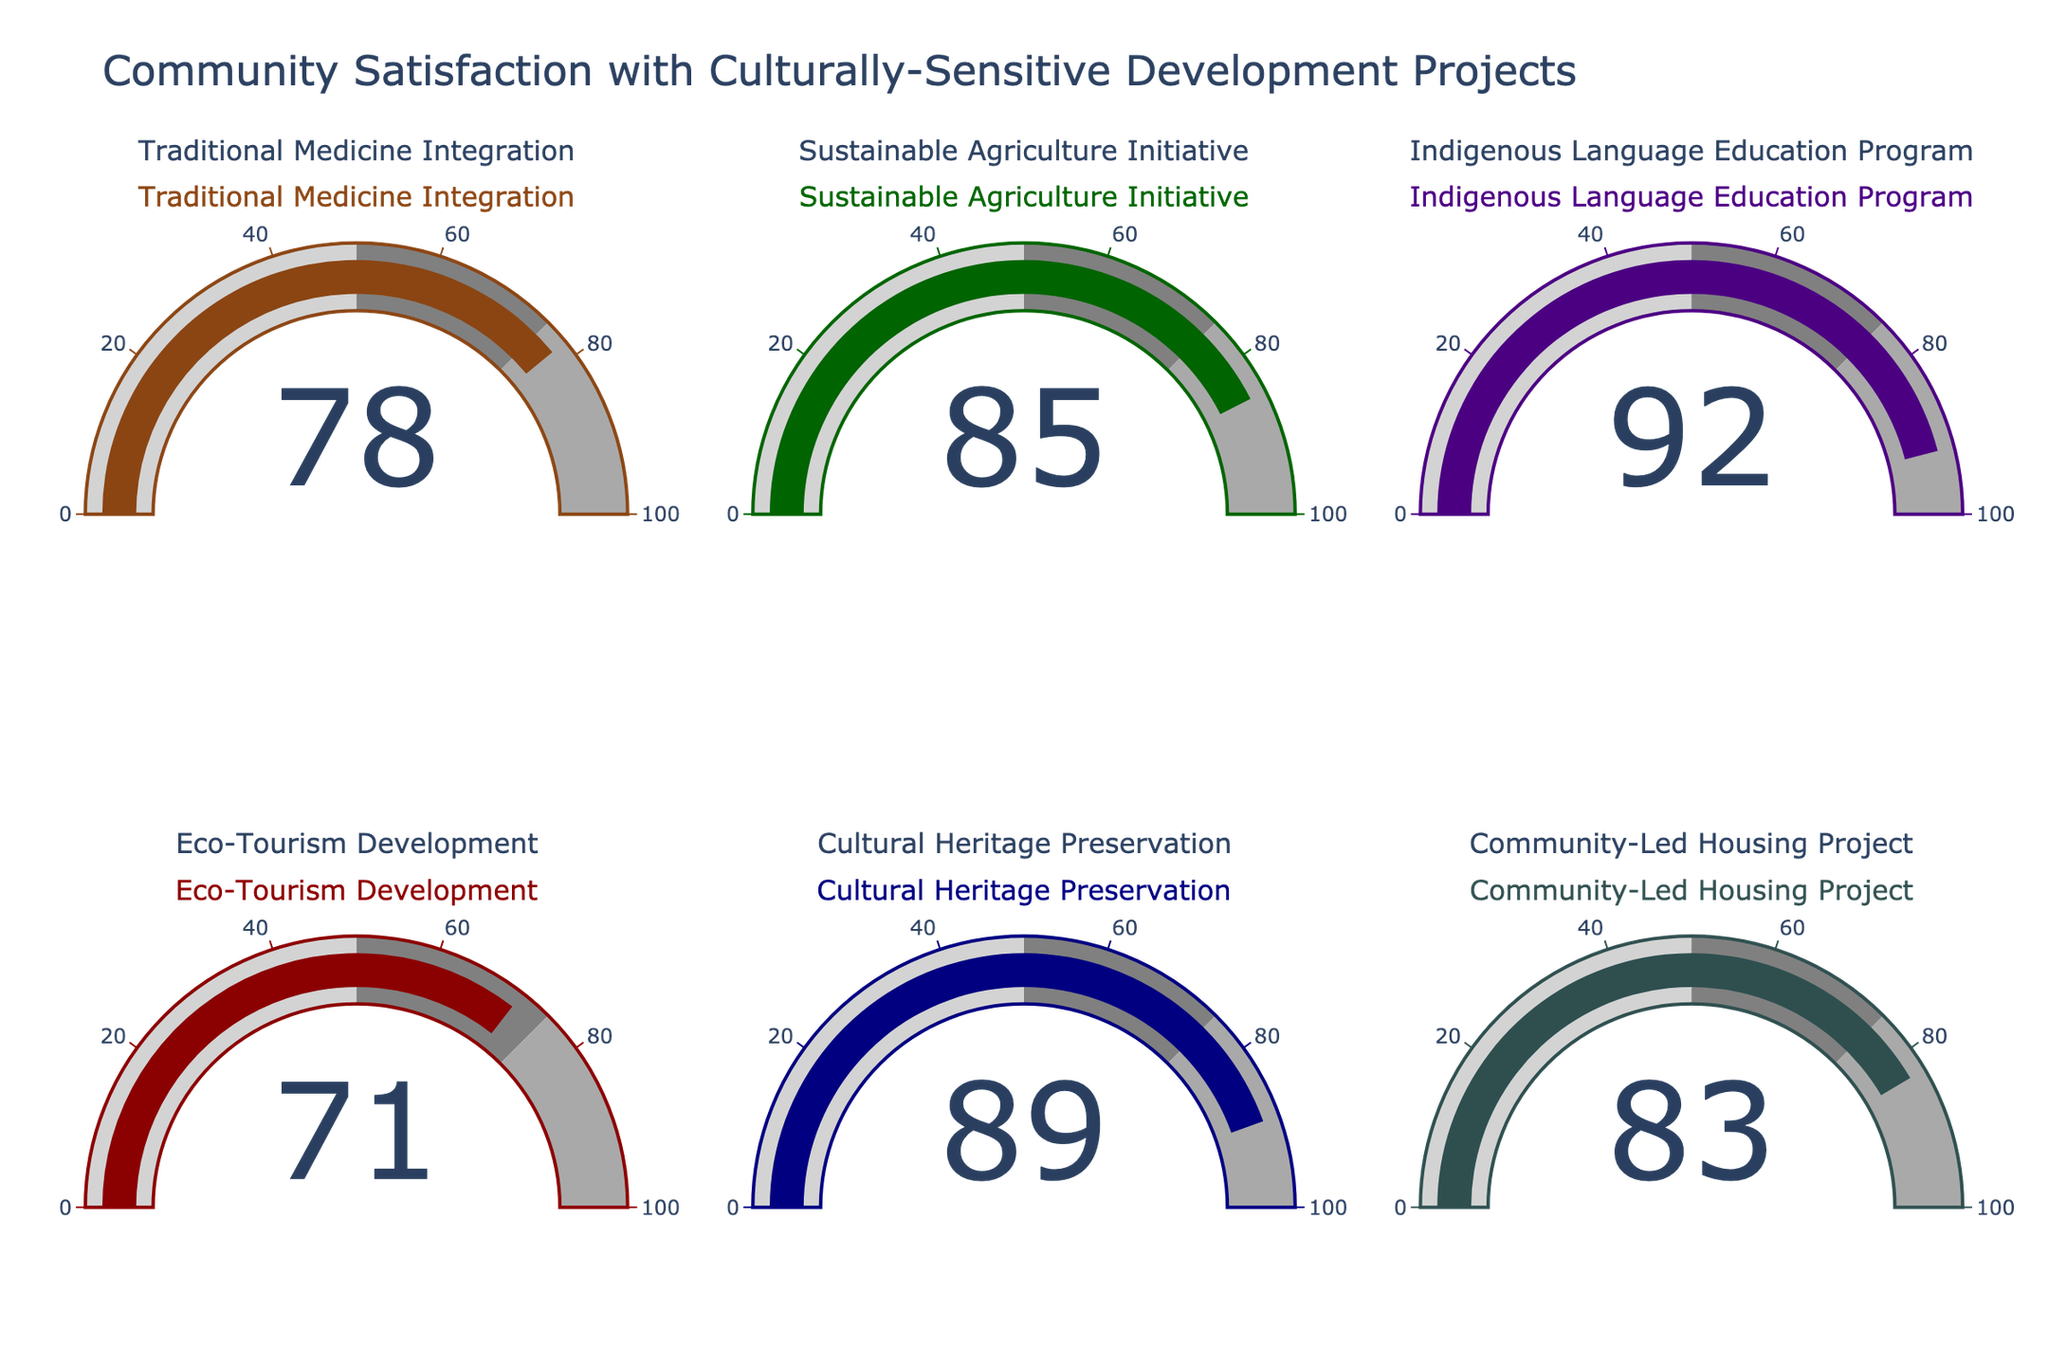What's the highest satisfaction level shown on the chart? The highest satisfaction level is shown in the gauge for the Indigenous Language Education Program, with a level of 92.
Answer: 92 Which project has the lowest satisfaction level? The Eco-Tourism Development project has the lowest satisfaction level, which is indicated as 71 on the gauge.
Answer: Eco-Tourism Development How many projects have a satisfaction level above 80? By counting the number of gauges with a value above 80: Traditional Medicine Integration (78) is below 80, Sustainable Agriculture Initiative (85) is above 80, Indigenous Language Education Program (92) is above 80, Eco-Tourism Development (71) is below 80, Cultural Heritage Preservation (89) is above 80, Community-Led Housing Project (83) is above 80. So, there are four projects with satisfaction levels above 80.
Answer: 4 What is the average satisfaction level for all projects? Sum all satisfaction levels: 78 (Traditional Medicine Integration) + 85 (Sustainable Agriculture Initiative) + 92 (Indigenous Language Education Program) + 71 (Eco-Tourism Development) + 89 (Cultural Heritage Preservation) + 83 (Community-Led Housing Project) = 498. Then divide by the number of projects, which is 6. The average satisfaction level is 498 / 6 = 83.
Answer: 83 Which two projects have the closest satisfaction levels, and what is the difference between them? Checking the differences: Traditional Medicine Integration (78) and Sustainable Agriculture Initiative (85) have a difference of 7, Traditional Medicine Integration (78) and Indigenous Language Education Program (92) have a difference of 14, and the closest difference is between Community-Led Housing Project (83) and Sustainable Agriculture Initiative (85), which is 2.
Answer: Community-Led Housing Project and Sustainable Agriculture Initiative, difference of 2 What is the median satisfaction level of all projects? To find the median, list the satisfaction levels in ascending order: 71, 78, 83, 85, 89, 92. Since there are six values, the median is the average of the third and fourth values: (83 + 85) / 2 = 84.
Answer: 84 Which project falls within the 75-100 range of satisfaction level but is not the highest? The range 75-100 includes Traditional Medicine Integration (78), Sustainable Agriculture Initiative (85), Indigenous Language Education Program (92), Cultural Heritage Preservation (89), and Community-Led Housing Project (83). The one that is not the highest among these is Cultural Heritage Preservation (89), as it isn't the highest but falls within the range.
Answer: Cultural Heritage Preservation What level of satisfaction does the Traditional Medicine Integration project have? As per the gauge chart, the Traditional Medicine Integration project has a satisfaction level of 78.
Answer: 78 Which project has a satisfaction level closest to 90? Comparing all satisfaction levels to 90, the Cultural Heritage Preservation project with a satisfaction level of 89 is closest.
Answer: Cultural Heritage Preservation 